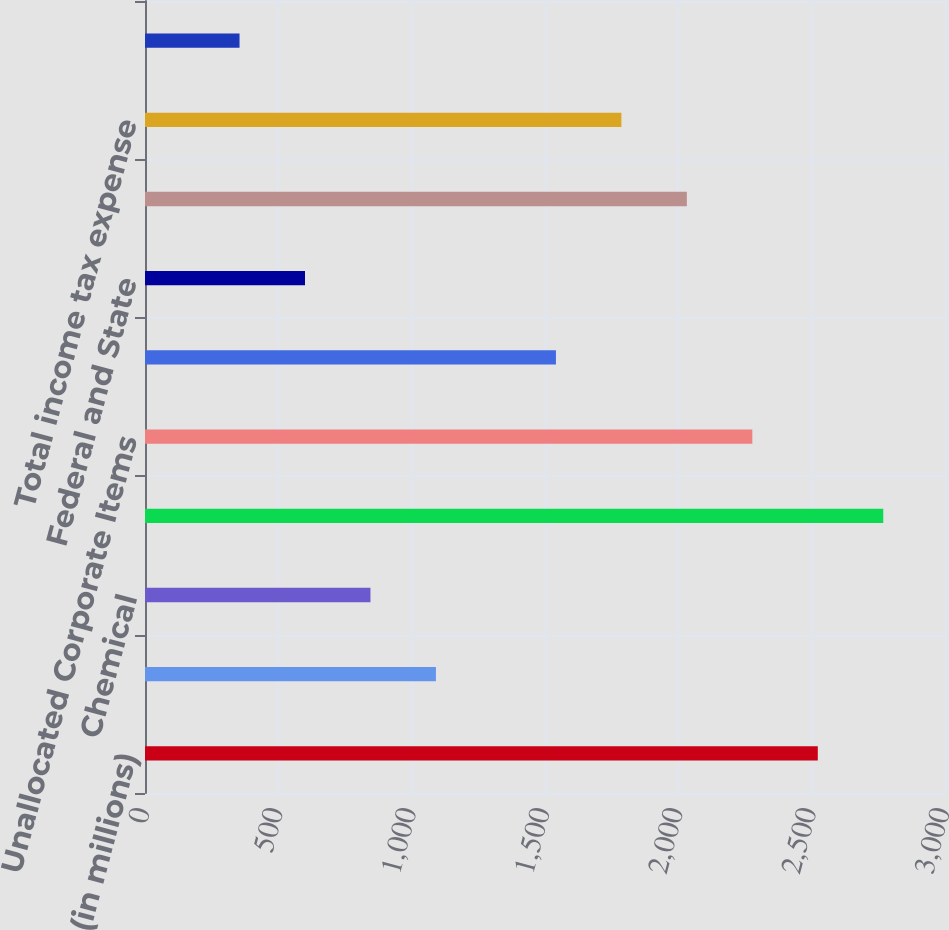Convert chart to OTSL. <chart><loc_0><loc_0><loc_500><loc_500><bar_chart><fcel>(in millions)<fcel>Oil and Gas<fcel>Chemical<fcel>Midstream and Marketing (a)<fcel>Unallocated Corporate Items<fcel>Pre-tax income<fcel>Federal and State<fcel>Foreign<fcel>Total income tax expense<fcel>Income (loss) from continuing<nl><fcel>2523<fcel>1091<fcel>845.5<fcel>2768.5<fcel>2277.5<fcel>1541<fcel>600<fcel>2032<fcel>1786.5<fcel>354.5<nl></chart> 